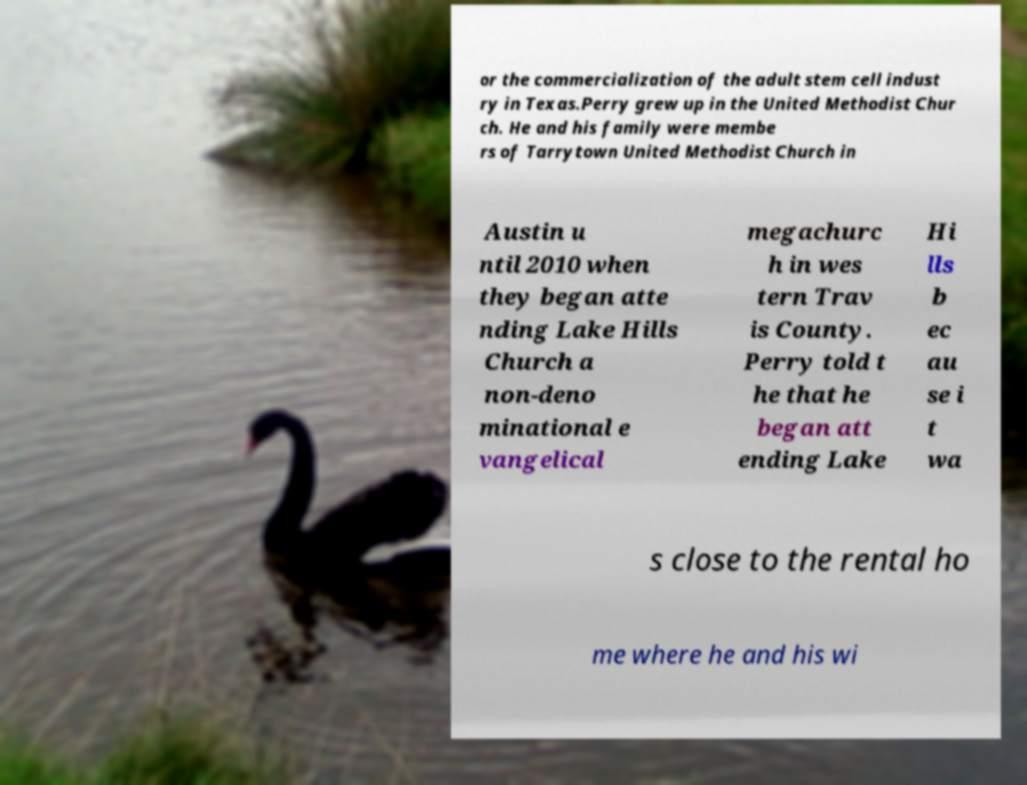Please read and relay the text visible in this image. What does it say? or the commercialization of the adult stem cell indust ry in Texas.Perry grew up in the United Methodist Chur ch. He and his family were membe rs of Tarrytown United Methodist Church in Austin u ntil 2010 when they began atte nding Lake Hills Church a non-deno minational e vangelical megachurc h in wes tern Trav is County. Perry told t he that he began att ending Lake Hi lls b ec au se i t wa s close to the rental ho me where he and his wi 